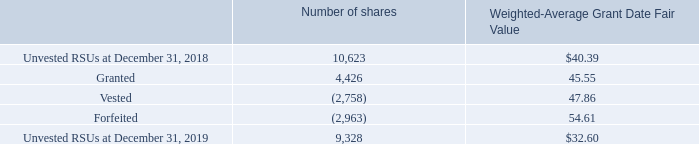RSU Activity We grant RSUs, which represent the right to receive shares of our common stock. Vesting for RSUs is contingent upon the holders’ continued employment with us and may be subject to other conditions (which may include the satisfaction of a performance measure). Also, certain of our performance-based RSUs include a range of shares that may be released at vesting which are above or below the targeted number of RSUs based on actual performance relative to the grant date performance measure. If the vesting conditions are not met, unvested RSUs will be forfeited. Upon vesting of the RSUs, we may withhold shares otherwise deliverable to satisfy tax withholding requirements.
The following table summarizes our RSU activity with performance-based RSUs presented at the maximum potential shares that could be earned and issued at vesting (amounts in thousands except per share amounts):
Certain of our performance-based RSUs did not have an accounting grant date as of December 31, 2019, as there is not a mutual understanding between the Company and the employee of the performance terms. Generally, these performance terms relate to operating income performance for future years where the performance goals have not yet been set. As of December 31, 2019, there were 3.2 million performance-based RSUs outstanding for which the accounting grant date has not been set, of which 1.9 million were 2019 grants. Accordingly, no grant date fair value was established and the weighted average grant date fair value calculated above for 2019 grants excludes these RSUs.
At December 31, 2019, approximately $96 million of total unrecognized compensation cost was related to RSUs and is expected to be recognized over a weighted-average period of 1.64 years. Of the total unrecognized compensation cost, $50 million was related to performance-based RSUs, which is expected to be recognized over a weighted-average period of 1.63 years. The total grant date fair value of vested RSUs was $147 million, $120 million and $64 million for the years ended December 31, 2019, 2018, and 2017, respectively.
The income tax benefit from stock option exercises and RSU vestings was $47 million, $94 million, and $160 million for the years ended December 31, 2019, 2018, and 2017, respectively.
What was the total grant date fair value of vested RSUs in 2019?
Answer scale should be: million. $147 million. What was the total grant date fair value of vested RSUs in 2018?
Answer scale should be: million. $120 million. What was the income tax benefit from stock option exercises and RSU vestings in 2017?
Answer scale should be: million. $160 million. What is the change in the number of unvested RSUs between 2018 and 2019?
Answer scale should be: thousand. 9,328-10,623
Answer: -1295. What is the difference in the weighted-average grant date fair value between granted and vested RSUs? 47.86-45.55
Answer: 2.31. What is the difference in the weighted-average grant date fair value between granted and forfeited RSUs? 54.61-45.55
Answer: 9.06. 